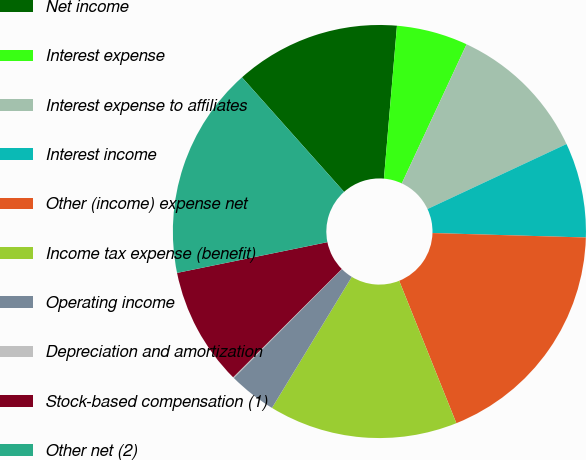Convert chart. <chart><loc_0><loc_0><loc_500><loc_500><pie_chart><fcel>Net income<fcel>Interest expense<fcel>Interest expense to affiliates<fcel>Interest income<fcel>Other (income) expense net<fcel>Income tax expense (benefit)<fcel>Operating income<fcel>Depreciation and amortization<fcel>Stock-based compensation (1)<fcel>Other net (2)<nl><fcel>12.94%<fcel>5.58%<fcel>11.1%<fcel>7.42%<fcel>18.46%<fcel>14.78%<fcel>3.75%<fcel>0.07%<fcel>9.26%<fcel>16.62%<nl></chart> 